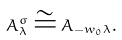Convert formula to latex. <formula><loc_0><loc_0><loc_500><loc_500>A _ { \lambda } ^ { \sigma } \cong A _ { - w _ { 0 } \lambda } .</formula> 